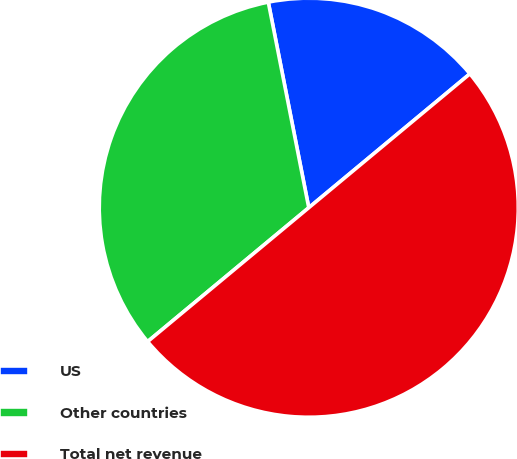Convert chart. <chart><loc_0><loc_0><loc_500><loc_500><pie_chart><fcel>US<fcel>Other countries<fcel>Total net revenue<nl><fcel>17.06%<fcel>32.94%<fcel>50.0%<nl></chart> 